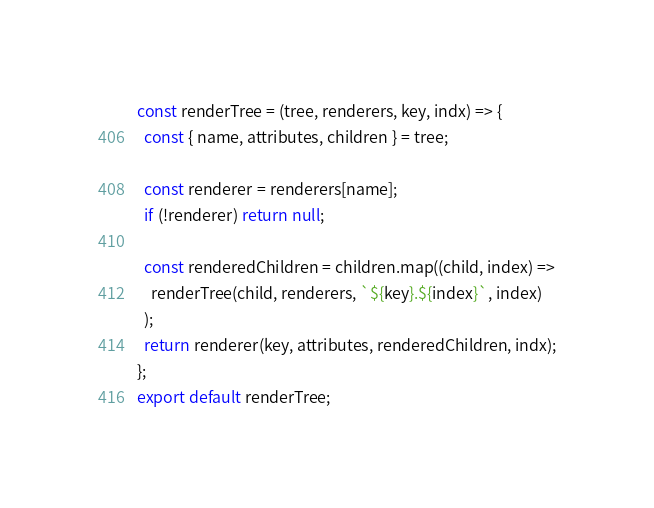<code> <loc_0><loc_0><loc_500><loc_500><_JavaScript_>const renderTree = (tree, renderers, key, indx) => {
  const { name, attributes, children } = tree;

  const renderer = renderers[name];
  if (!renderer) return null;

  const renderedChildren = children.map((child, index) =>
    renderTree(child, renderers, `${key}.${index}`, index)
  );
  return renderer(key, attributes, renderedChildren, indx);
};
export default renderTree;
</code> 